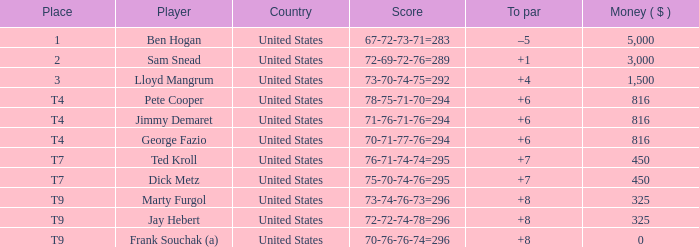What was marty furgol's standing when his compensation was below $3,000? T9. 